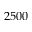<formula> <loc_0><loc_0><loc_500><loc_500>2 5 0 0</formula> 